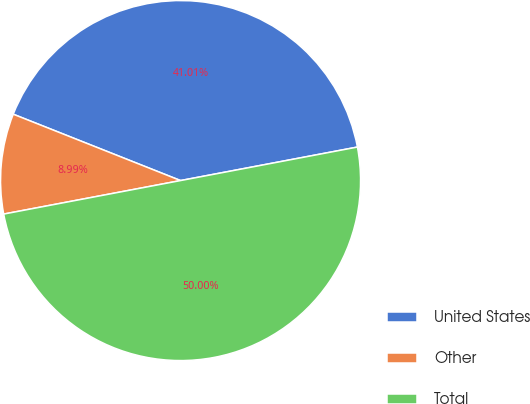Convert chart. <chart><loc_0><loc_0><loc_500><loc_500><pie_chart><fcel>United States<fcel>Other<fcel>Total<nl><fcel>41.01%<fcel>8.99%<fcel>50.0%<nl></chart> 